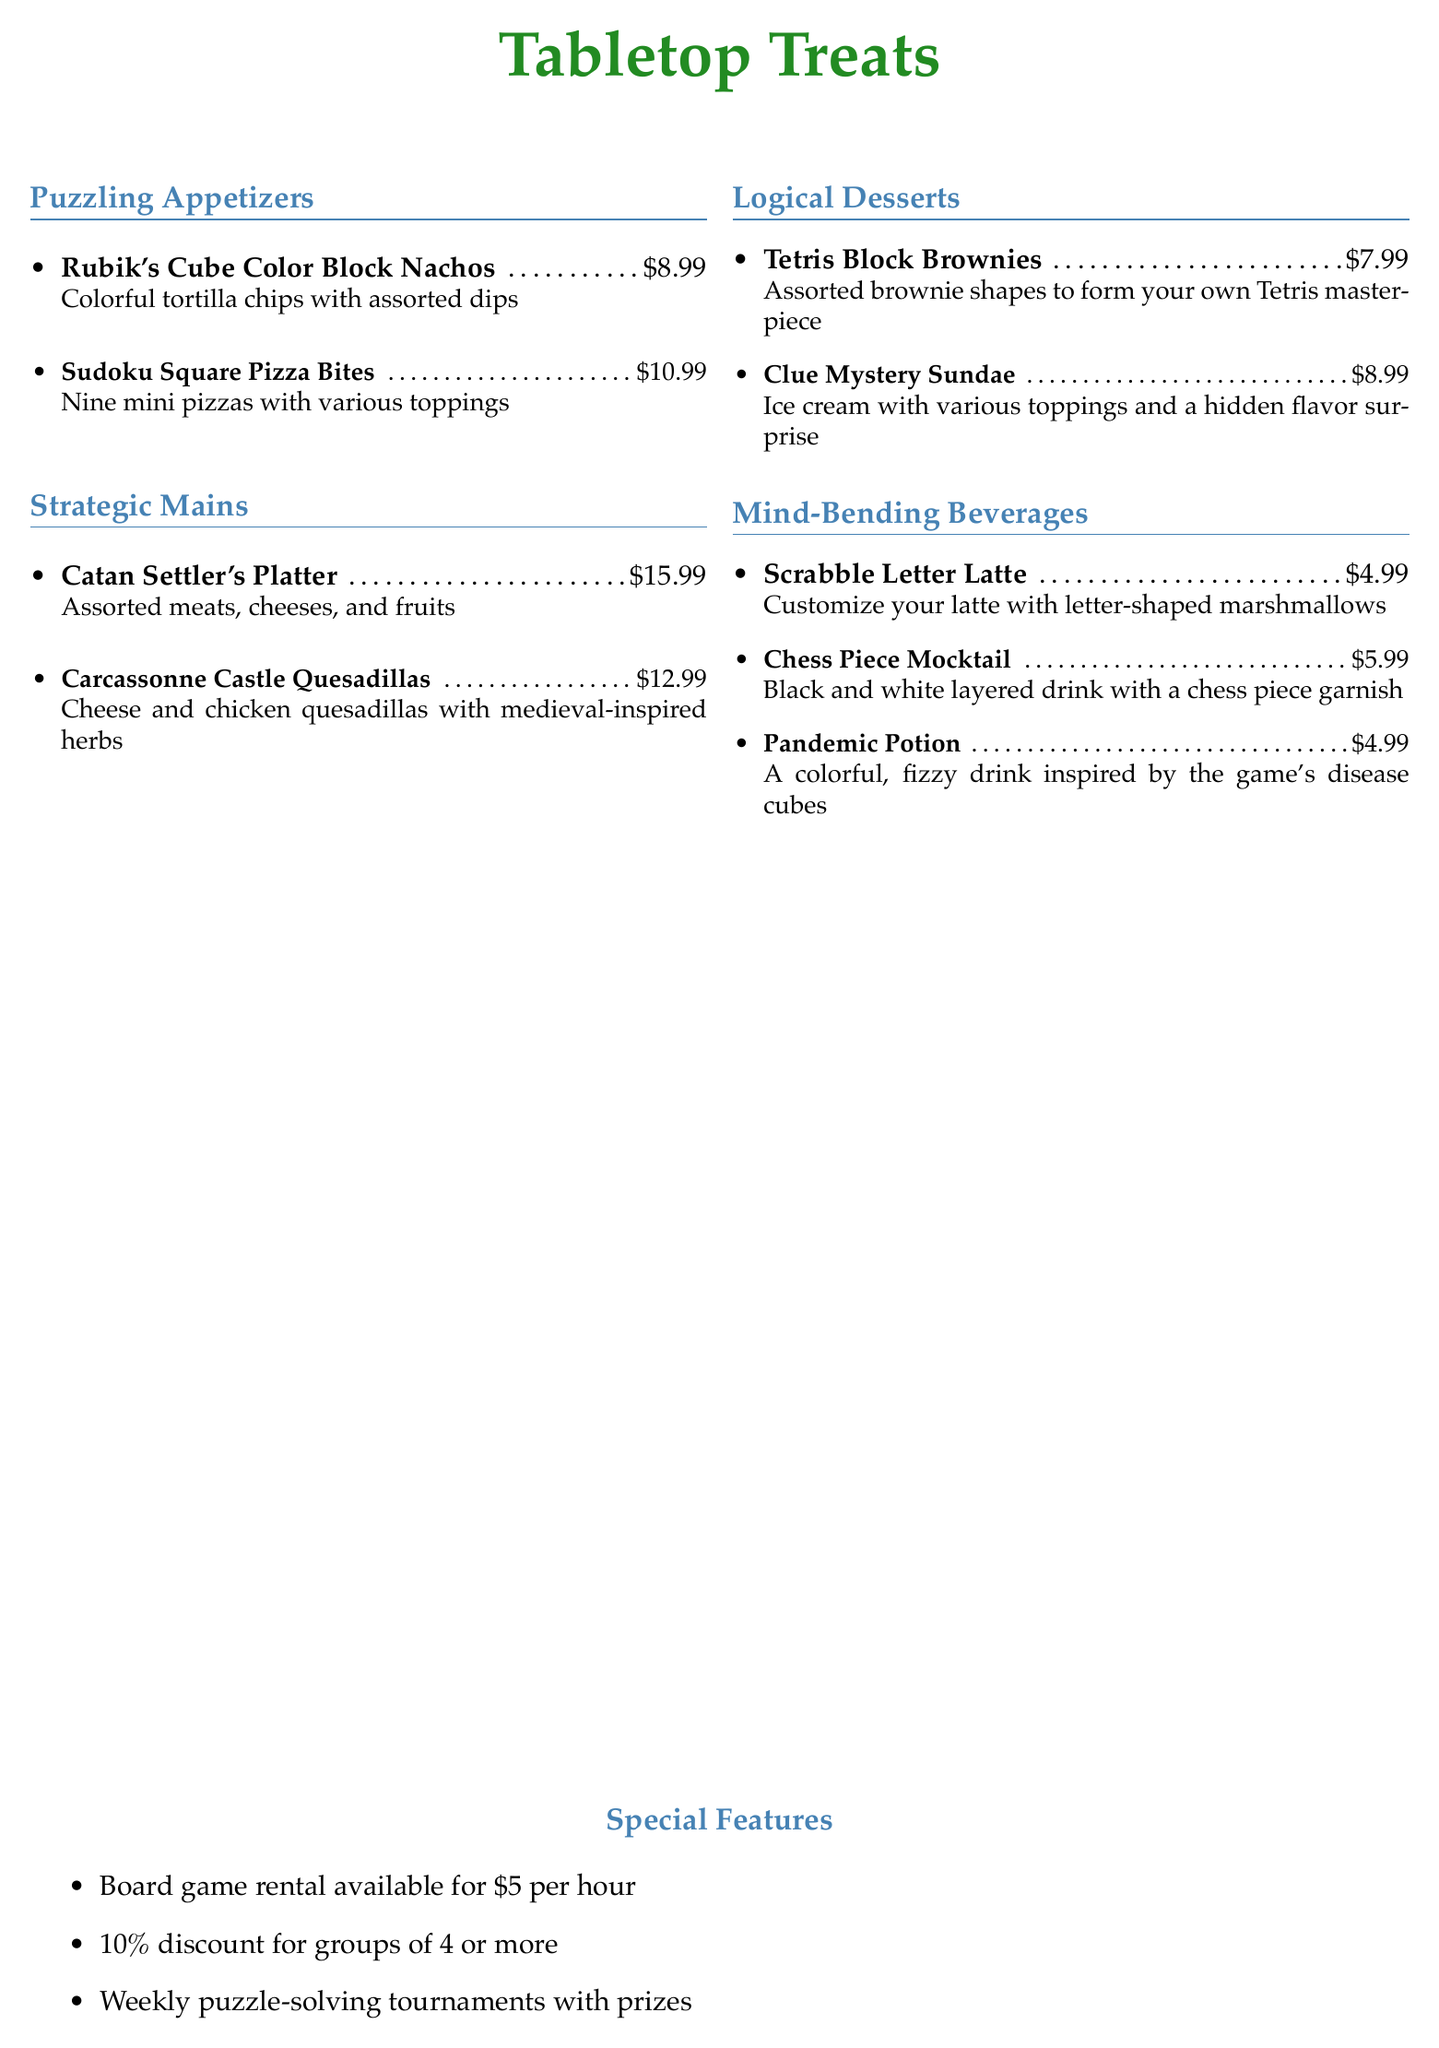What is the price of the Rubik's Cube Color Block Nachos? The price for the Rubik's Cube Color Block Nachos is listed under the Puzzling Appetizers section.
Answer: $8.99 How many mini pizzas are included in the Sudoku Square Pizza Bites? The Sudoku Square Pizza Bites are described as having nine mini pizzas with various toppings.
Answer: Nine What is the main ingredient in the Carcassonne Castle Quesadillas? The main ingredient in the Carcassonne Castle Quesadillas is cheese and chicken with medieval-inspired herbs.
Answer: Cheese and chicken What is the price of a Chess Piece Mocktail? The Chess Piece Mocktail's price is provided in the Mind-Bending Beverages section.
Answer: $5.99 How much is the board game rental per hour? The document states that board game rental is available for a specific fee per hour.
Answer: $5 What discount is offered for groups of 4 or more? The document mentions a percentage discount applied to groups that meet a certain size.
Answer: 10% Which dessert features a hidden flavor surprise? Clue Mystery Sundae is described in the Logical Desserts section as having a hidden flavor surprise.
Answer: Clue Mystery Sundae What type of event does the cafe host weekly? The cafe hosts puzzle-solving tournaments, as stated in the Special Features section.
Answer: Puzzle-solving tournaments What is the colorful drink inspired by disease cubes called? The drink inspired by the game's disease cubes is mentioned in the Mind-Bending Beverages section.
Answer: Pandemic Potion 